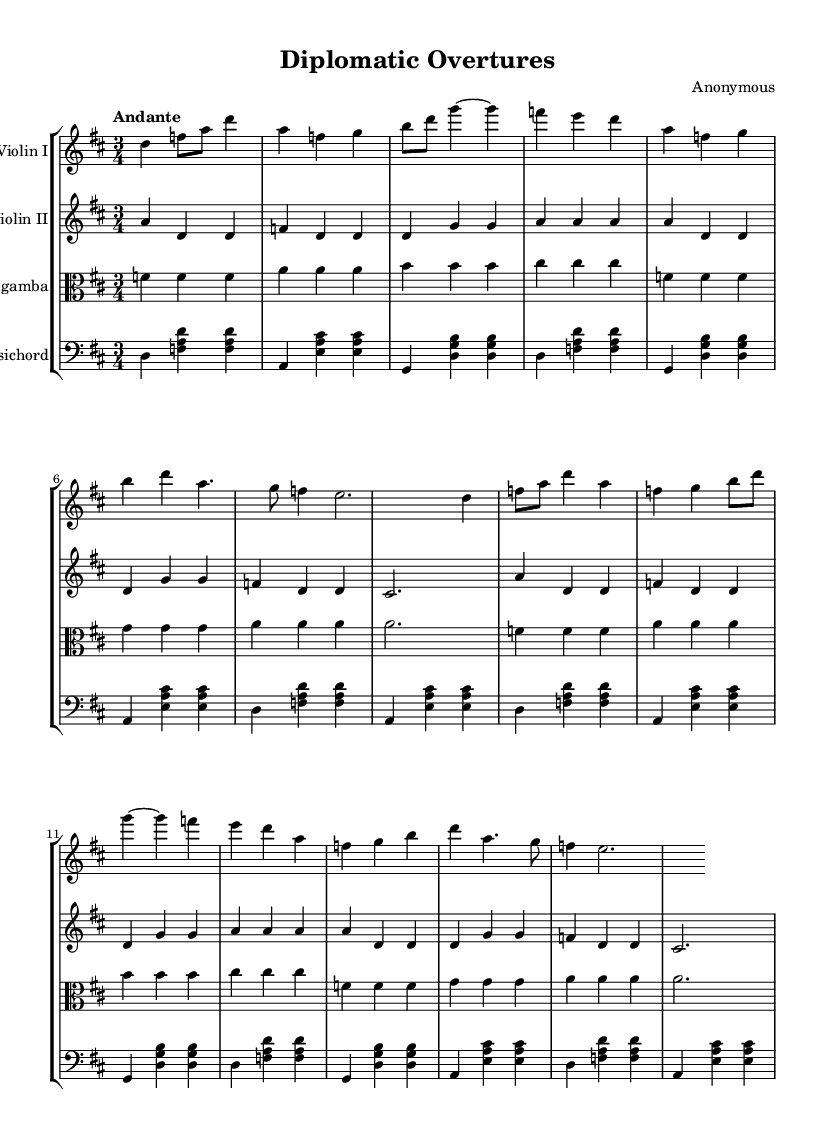What is the key signature of this music? The key signature is indicated by the presence of two sharps, which correspond to the notes F# and C#. Thus, the piece is in D major.
Answer: D major What is the time signature of the music? The time signature, shown at the beginning of the score, is 3/4, which means there are three beats in a measure and the quarter note gets one beat.
Answer: 3/4 What is the tempo marking of this piece? The tempo marking at the beginning indicates "Andante," which suggests a moderately slow pace.
Answer: Andante How many measures are in the A section of this piece? Since the A section consists of 16 bars as stated, and it repeats as indicated in the score, we conclude that there are 16 measures.
Answer: 16 What instruments are featured in this chamber music? The score lists four instruments: Violin I, Violin II, Viola da gamba, and Harpsichord, all typical of Baroque chamber music.
Answer: Violin I, Violin II, Viola da gamba, Harpsichord What is the role of the harpsichord in this piece? The harpsichord serves as a continuo instrument, providing harmonic support and elaboration, which is characteristic of Baroque music.
Answer: Continuo Which musical form is used in this piece? The structure of the piece, with clear repetition and sections, follows a simple A-section form that is frequently found in Baroque chamber music.
Answer: A-section form 